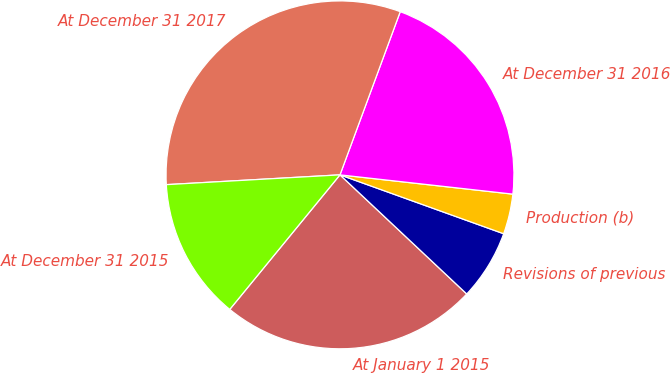Convert chart. <chart><loc_0><loc_0><loc_500><loc_500><pie_chart><fcel>At January 1 2015<fcel>Revisions of previous<fcel>Production (b)<fcel>At December 31 2016<fcel>At December 31 2017<fcel>At December 31 2015<nl><fcel>23.92%<fcel>6.51%<fcel>3.73%<fcel>21.14%<fcel>31.53%<fcel>13.18%<nl></chart> 